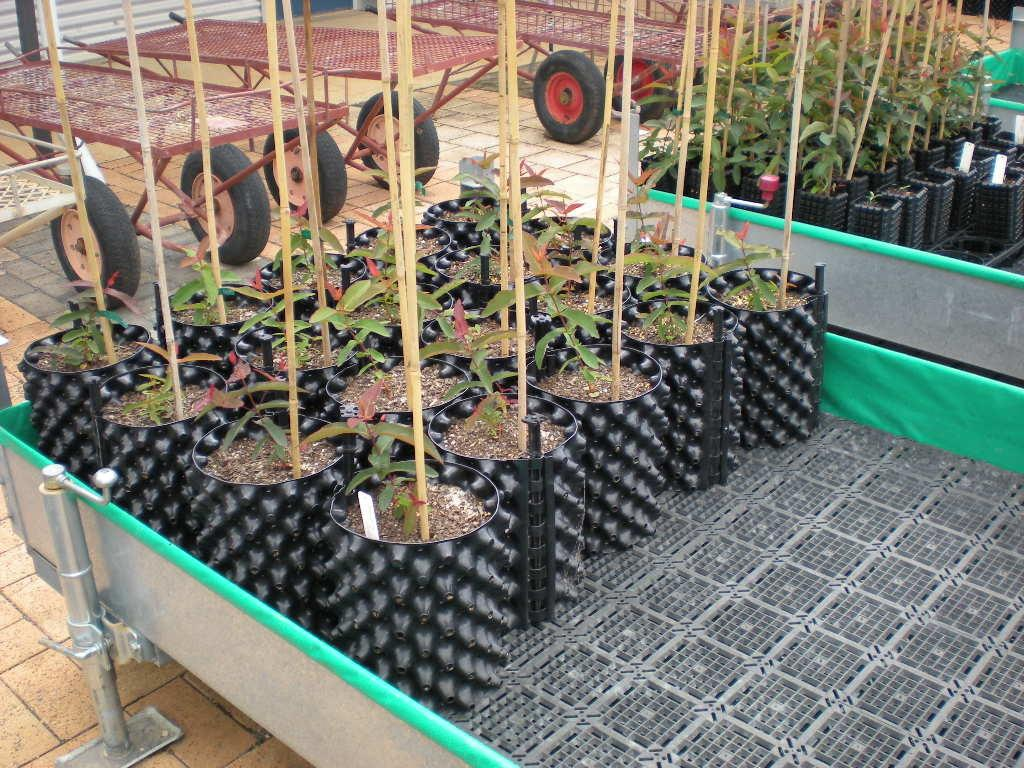What is placed on the tray in the image? There are plants on a tray in the image. What type of objects are present in the image besides the plants on the tray? There are trolleys in the image. What type of lace can be seen on the plants in the image? There is no lace present on the plants in the image; they are simply plants on a tray. 